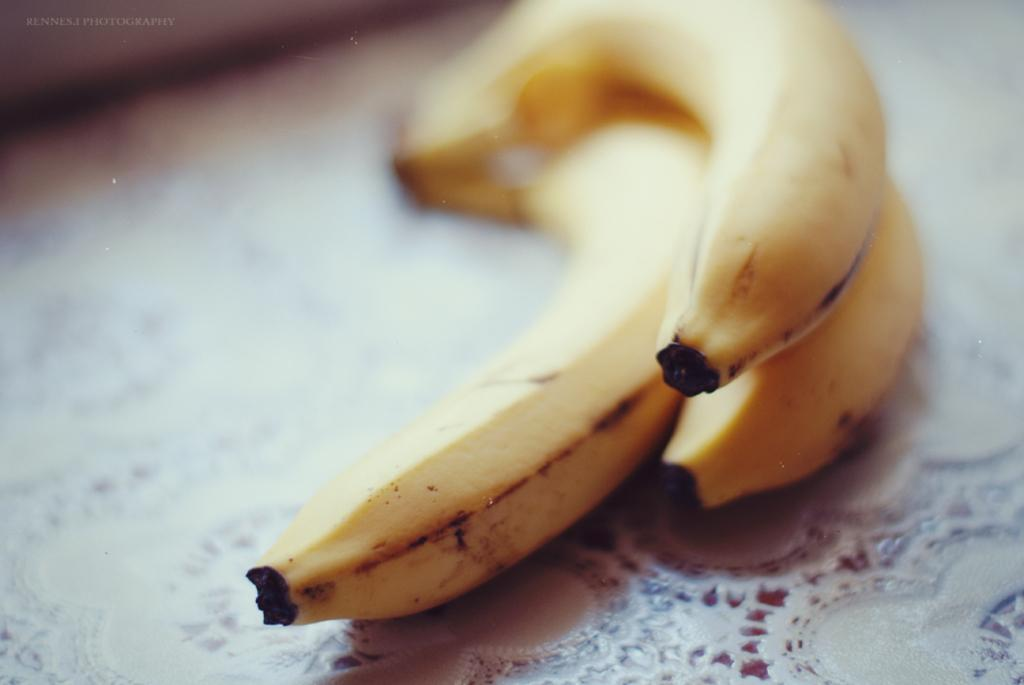How many bananas are visible in the image? There are three bananas in the image. What colors are the bananas? The bananas are yellow and black in color. What is the bananas resting on in the image? The bananas are on a white cloth. What type of arithmetic problem can be solved using the bananas in the image? There is no arithmetic problem present in the image, as it only features bananas on a white cloth. 